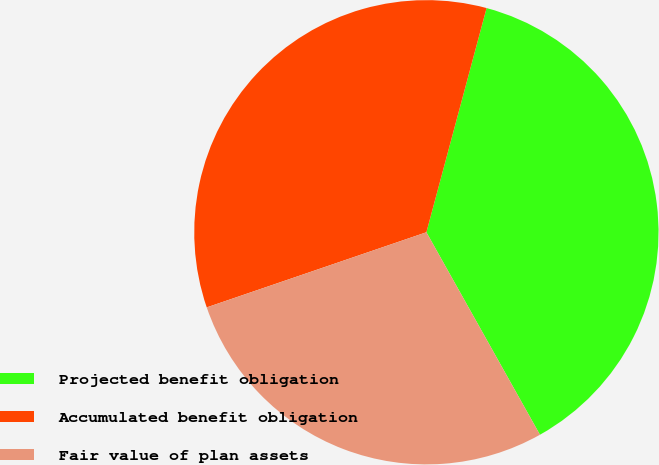<chart> <loc_0><loc_0><loc_500><loc_500><pie_chart><fcel>Projected benefit obligation<fcel>Accumulated benefit obligation<fcel>Fair value of plan assets<nl><fcel>37.69%<fcel>34.42%<fcel>27.89%<nl></chart> 